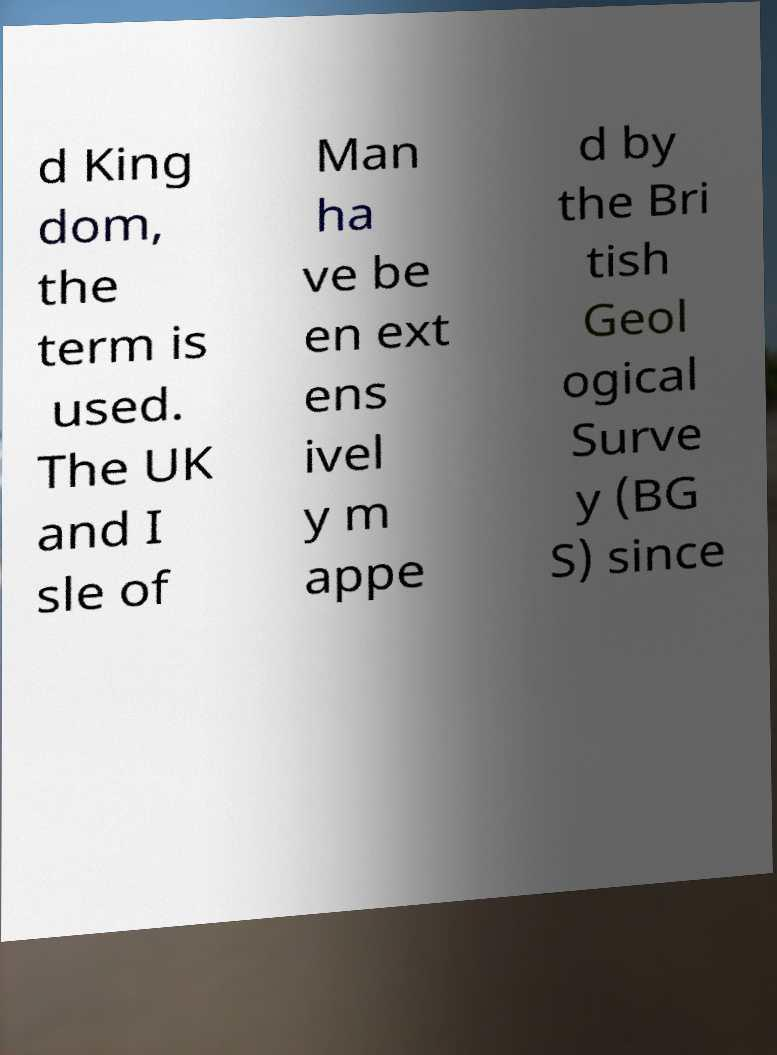Can you read and provide the text displayed in the image?This photo seems to have some interesting text. Can you extract and type it out for me? d King dom, the term is used. The UK and I sle of Man ha ve be en ext ens ivel y m appe d by the Bri tish Geol ogical Surve y (BG S) since 